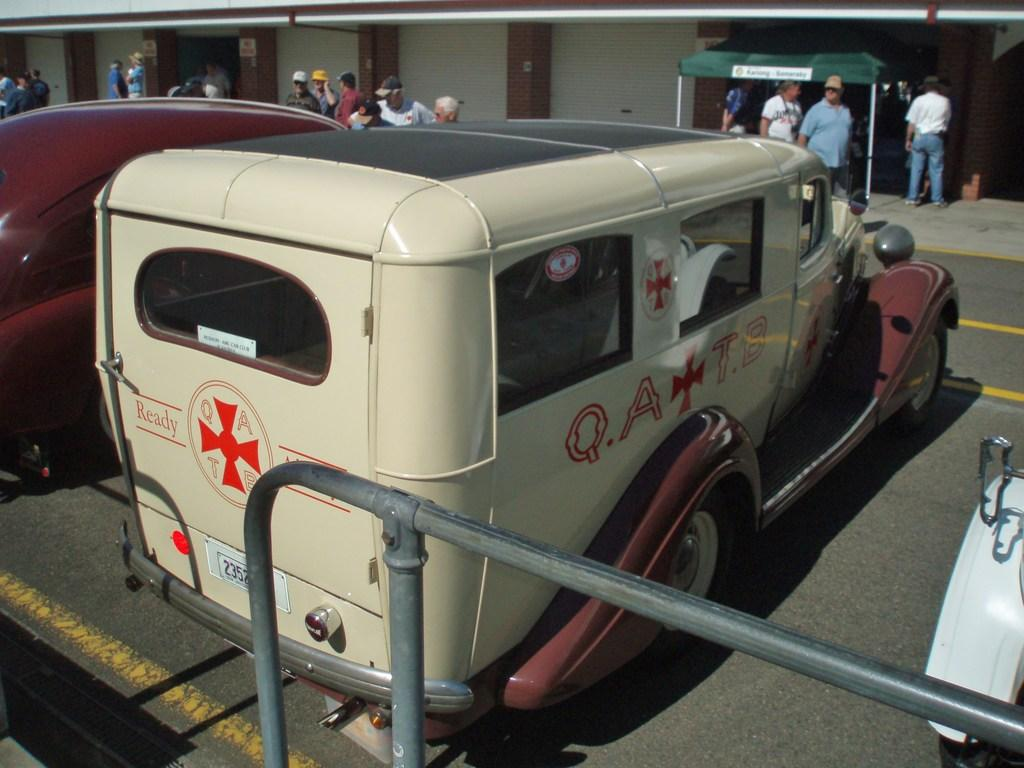What is located in the middle of the image? There are vehicles in the middle of the image. What can be seen in the background of the image? There are people and a wall in the background of the image. Can you describe the object at the bottom of the image? There is a metal object present at the bottom of the image. What type of record can be seen being played on the wall in the image? There is no record or any indication of music playing in the image. The wall is simply a part of the background. 